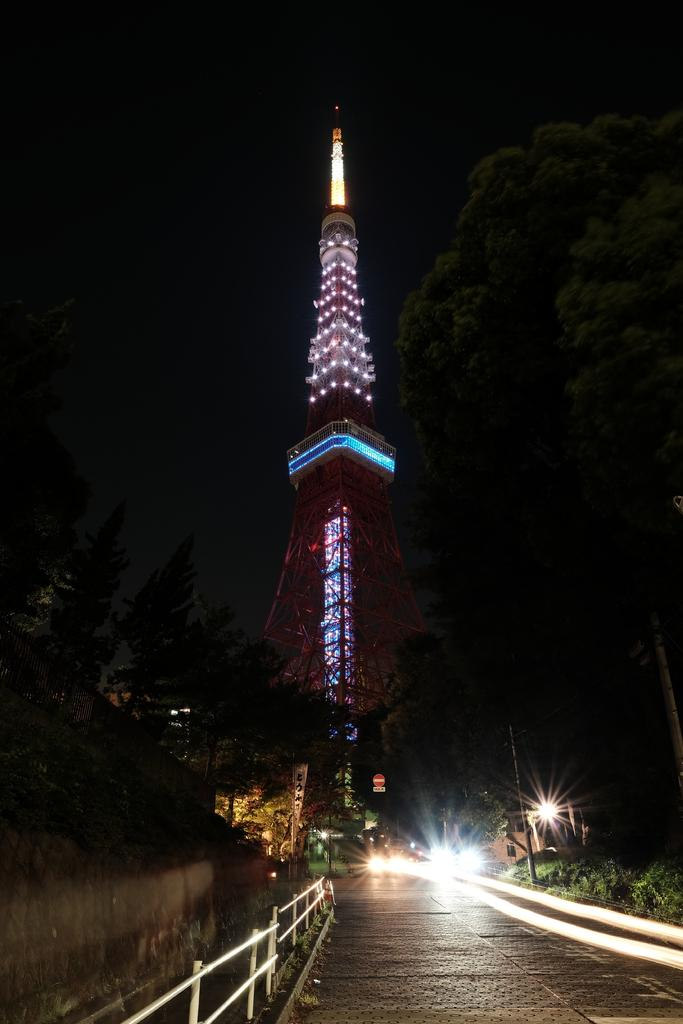What type of structures can be seen in the image? There are lights, railing, poles, and a tower visible in the image. What type of natural elements are present in the image? There are trees and plants in the image. What is the condition of the sky in the image? The sky is dark in the image. What type of company is being celebrated during the holiday meal in the image? There is no company, holiday, or meal present in the image. What type of food is being served at the holiday meal in the image? There is no holiday meal present in the image. 